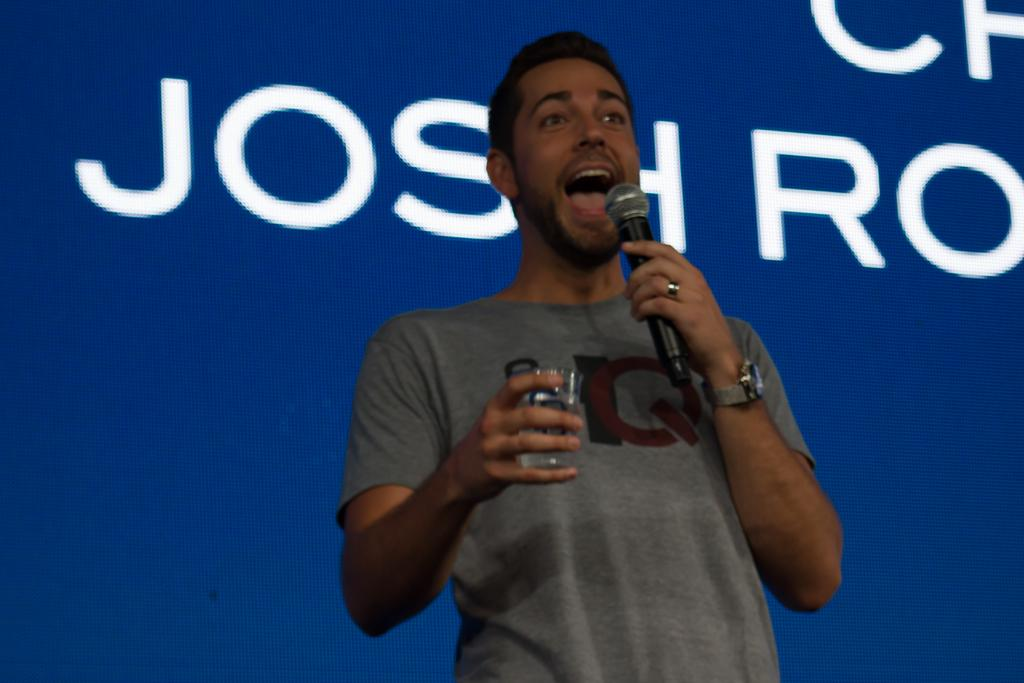What is the main subject of the image? The main subject of the image is a man. What is the man doing in the image? The man is speaking in the image. What objects is the man holding in the image? The man is holding a microphone in one hand and a glass in the other hand. What type of disease is the man discussing in the image? There is no indication in the image that the man is discussing any disease. 